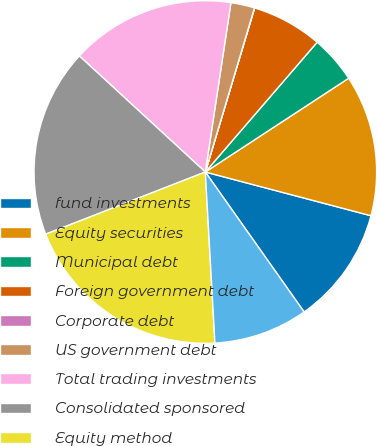Convert chart. <chart><loc_0><loc_0><loc_500><loc_500><pie_chart><fcel>fund investments<fcel>Equity securities<fcel>Municipal debt<fcel>Foreign government debt<fcel>Corporate debt<fcel>US government debt<fcel>Total trading investments<fcel>Consolidated sponsored<fcel>Equity method<fcel>Deferred compensation plan<nl><fcel>11.11%<fcel>13.33%<fcel>4.46%<fcel>6.67%<fcel>0.02%<fcel>2.24%<fcel>15.54%<fcel>17.76%<fcel>19.98%<fcel>8.89%<nl></chart> 